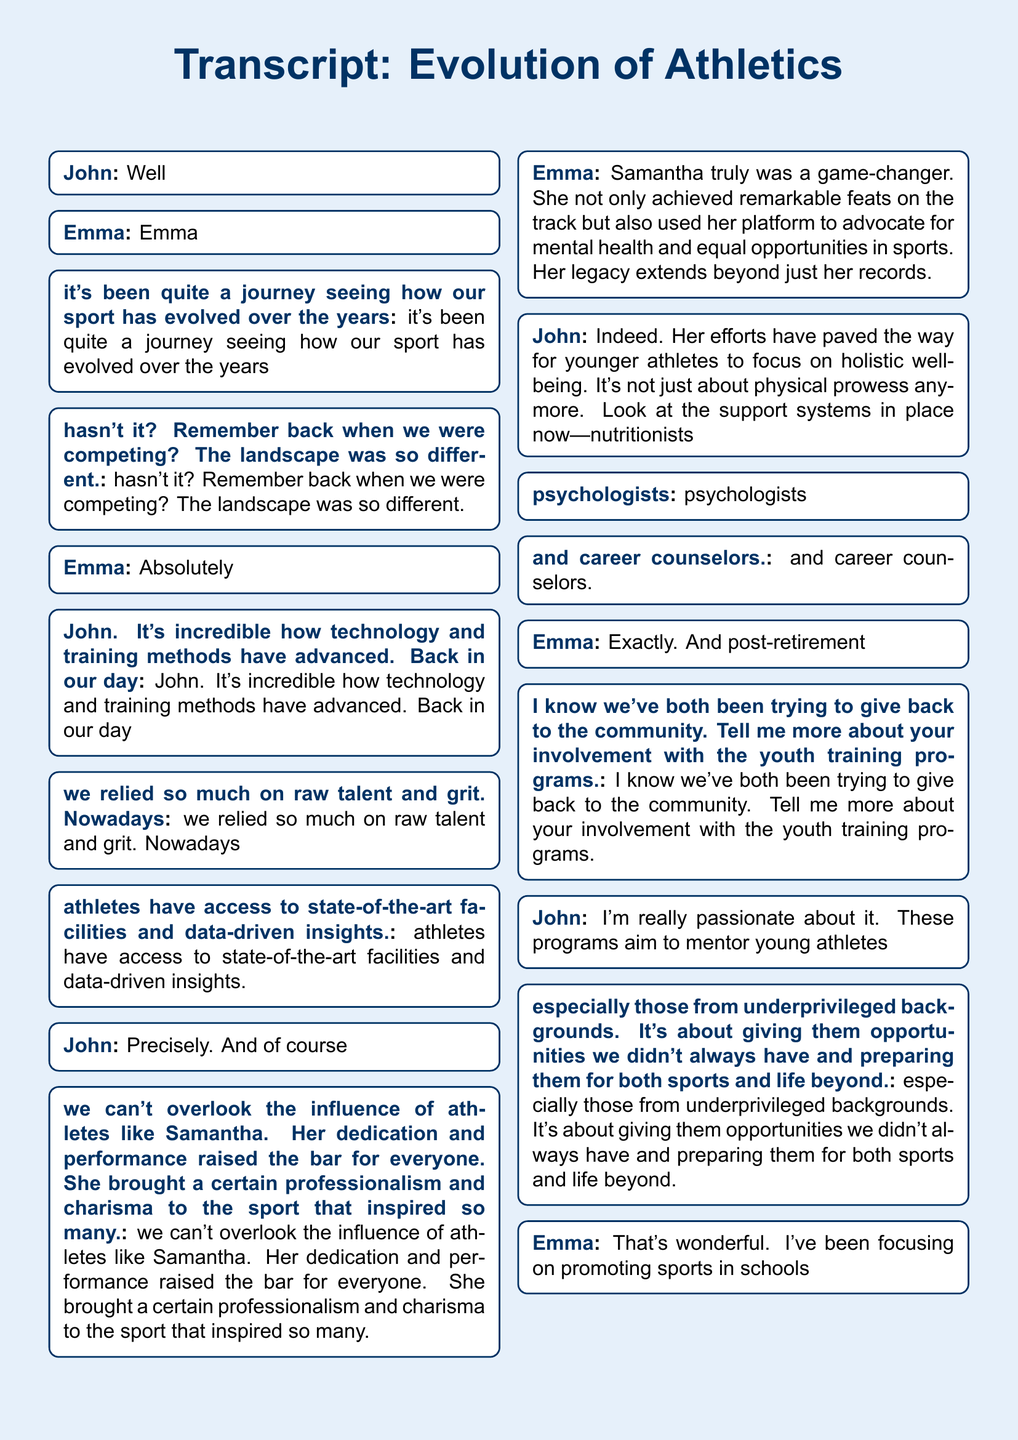What sport are John and Emma discussing? The sport they are discussing is athletics, as inferred from the context of their conversation.
Answer: athletics Who does John mention as an influential athlete? John refers to Samantha as an influential athlete in their discussion.
Answer: Samantha What aspect of Samantha's legacy does Emma highlight? Emma highlights Samantha's advocacy for mental health and equal opportunities in sports as part of her legacy.
Answer: advocacy for mental health and equal opportunities What are John’s youth training programs aimed at? John's youth training programs aim to mentor young athletes from underprivileged backgrounds.
Answer: mentor young athletes from underprivileged backgrounds What type of programs has Emma been promoting? Emma has been promoting sports in schools to advocate for better facilities and inclusion.
Answer: sports in schools What major change in the sport does Emma mention? Emma mentions that athletes now have access to state-of-the-art facilities and data-driven insights as a major change.
Answer: state-of-the-art facilities and data-driven insights What key theme relates to post-retirement contributions? The key theme relating to post-retirement contributions is about giving back to the community.
Answer: giving back to the community What do both John and Emma feel about their post-retirement contributions? Both John and Emma feel that their contributions now feel significant, if not more so than when they were competing.
Answer: significant contributions What is the document type of this text? The document is a transcript, as indicated in the title and content structure.
Answer: transcript 